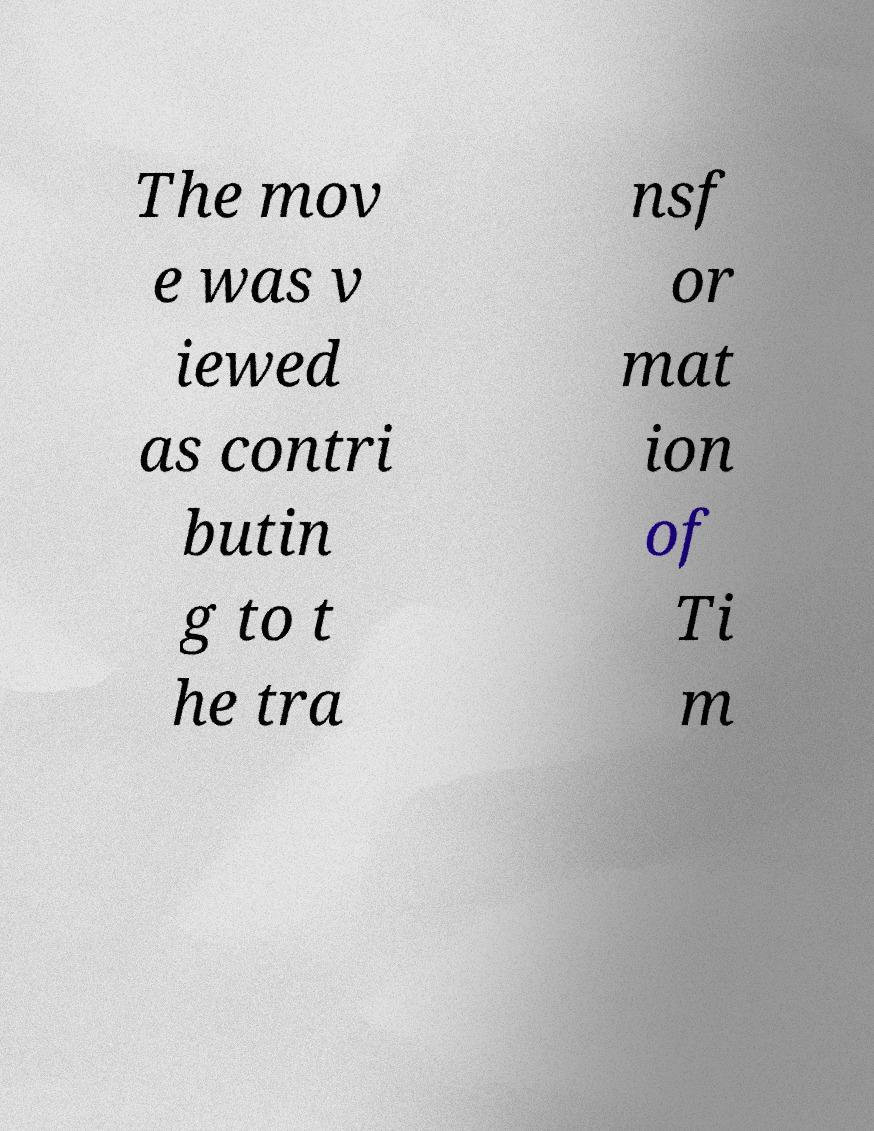Please read and relay the text visible in this image. What does it say? The mov e was v iewed as contri butin g to t he tra nsf or mat ion of Ti m 